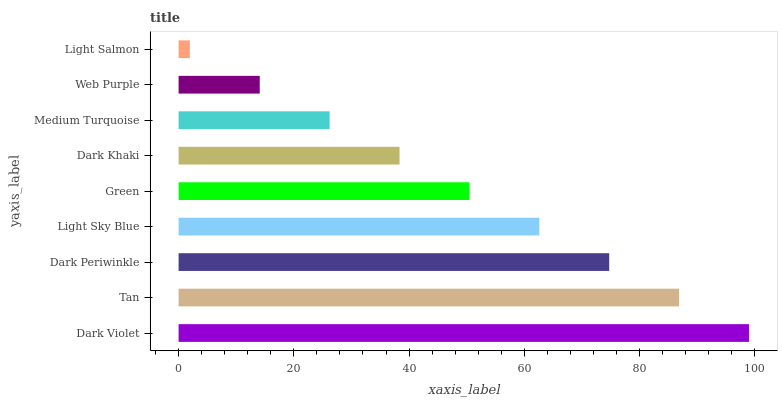Is Light Salmon the minimum?
Answer yes or no. Yes. Is Dark Violet the maximum?
Answer yes or no. Yes. Is Tan the minimum?
Answer yes or no. No. Is Tan the maximum?
Answer yes or no. No. Is Dark Violet greater than Tan?
Answer yes or no. Yes. Is Tan less than Dark Violet?
Answer yes or no. Yes. Is Tan greater than Dark Violet?
Answer yes or no. No. Is Dark Violet less than Tan?
Answer yes or no. No. Is Green the high median?
Answer yes or no. Yes. Is Green the low median?
Answer yes or no. Yes. Is Dark Violet the high median?
Answer yes or no. No. Is Light Salmon the low median?
Answer yes or no. No. 